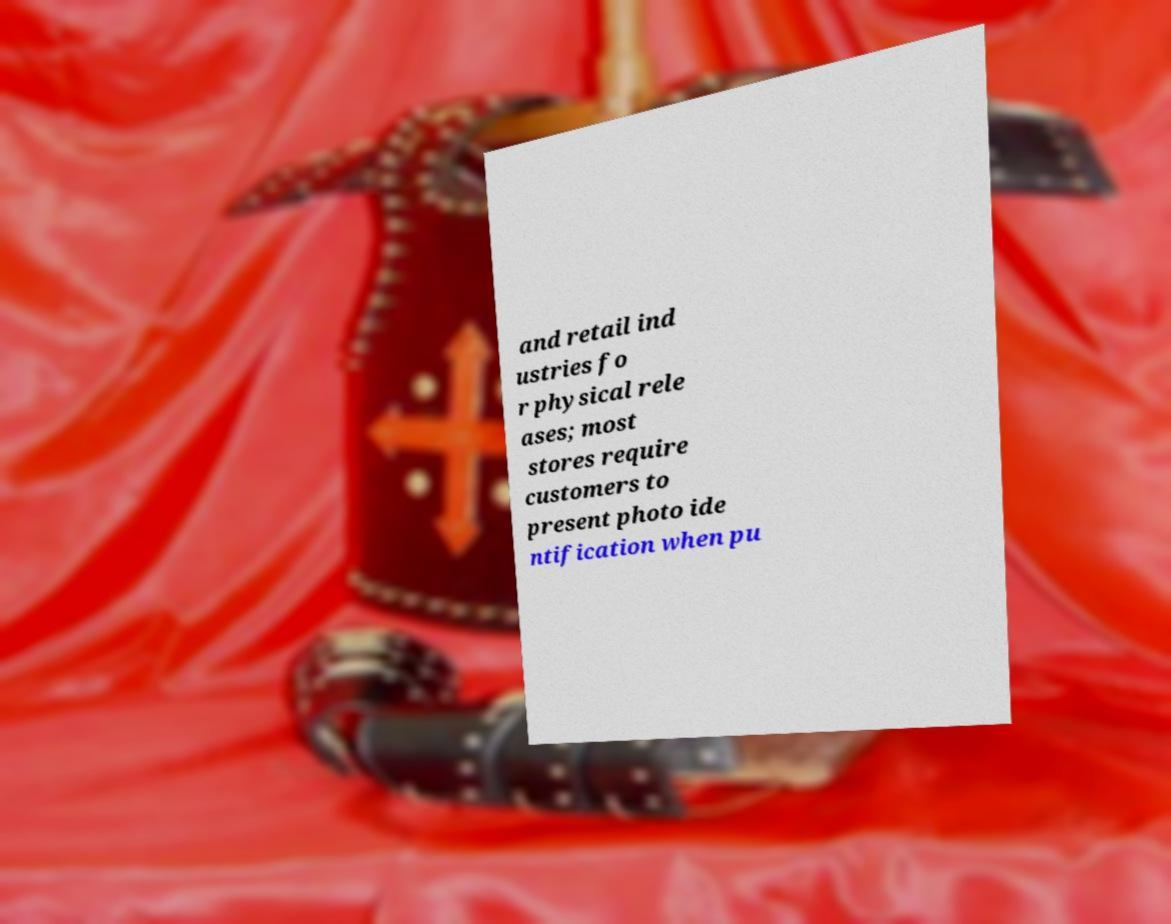There's text embedded in this image that I need extracted. Can you transcribe it verbatim? and retail ind ustries fo r physical rele ases; most stores require customers to present photo ide ntification when pu 